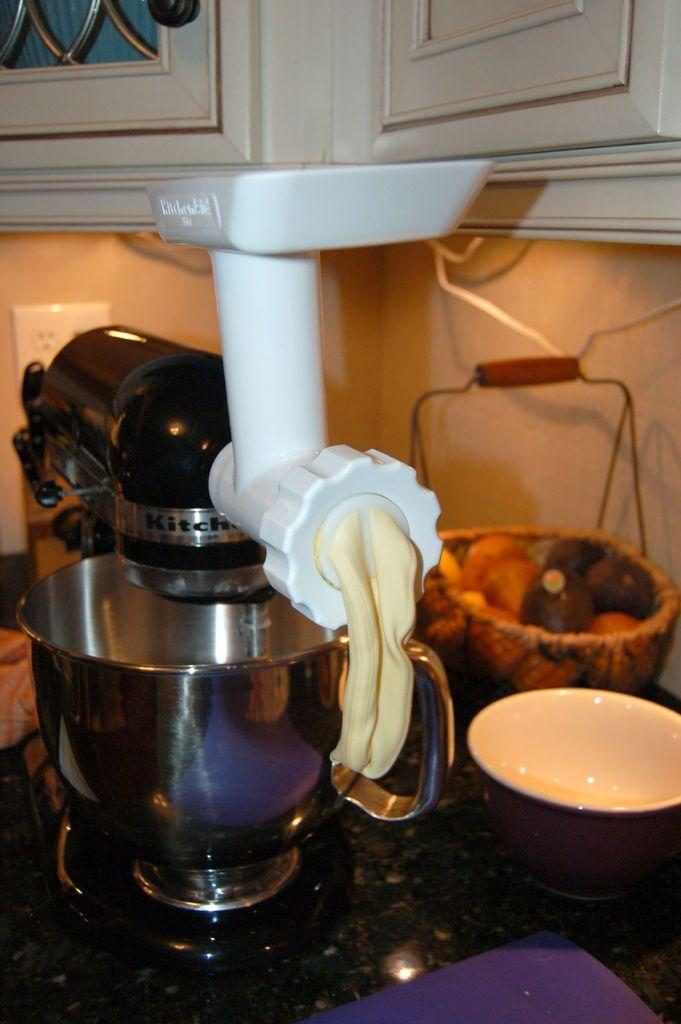What is the main object in the image? There is a cake beating machine in the image. What is the cake beating machine placed on? The cake beating machine is placed on a table in the image. What else can be seen on the table? There is a bowl and a basket of fruits on the table in the image. What is visible on the top part of the image? There are cupboards at the top of the image. What type of owl can be seen sitting on the cake beating machine in the image? There is no owl present in the image. The image only features a cake beating machine, a bowl, a basket of fruits, and cupboards. 